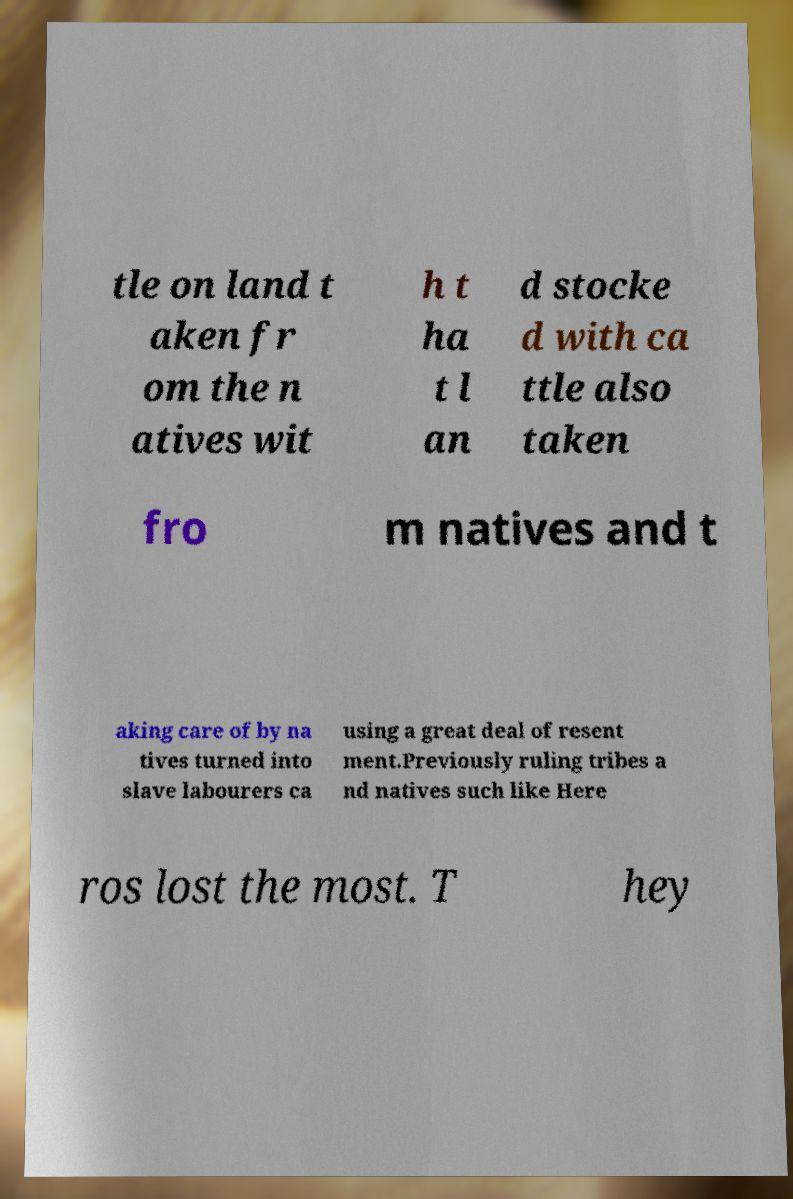Can you read and provide the text displayed in the image?This photo seems to have some interesting text. Can you extract and type it out for me? tle on land t aken fr om the n atives wit h t ha t l an d stocke d with ca ttle also taken fro m natives and t aking care of by na tives turned into slave labourers ca using a great deal of resent ment.Previously ruling tribes a nd natives such like Here ros lost the most. T hey 